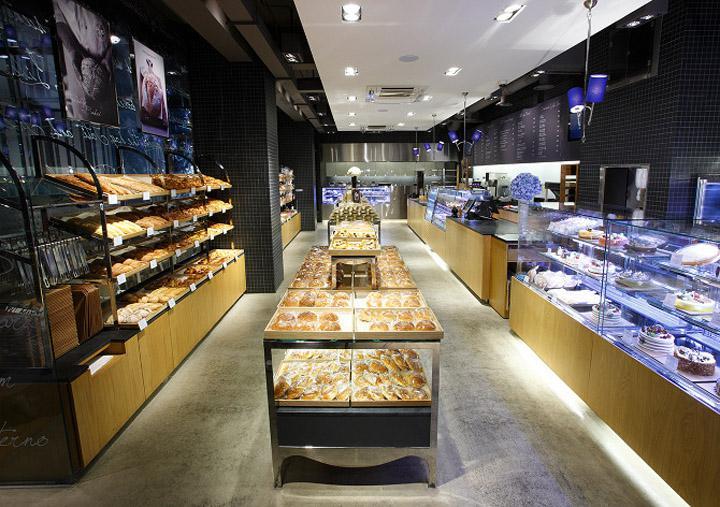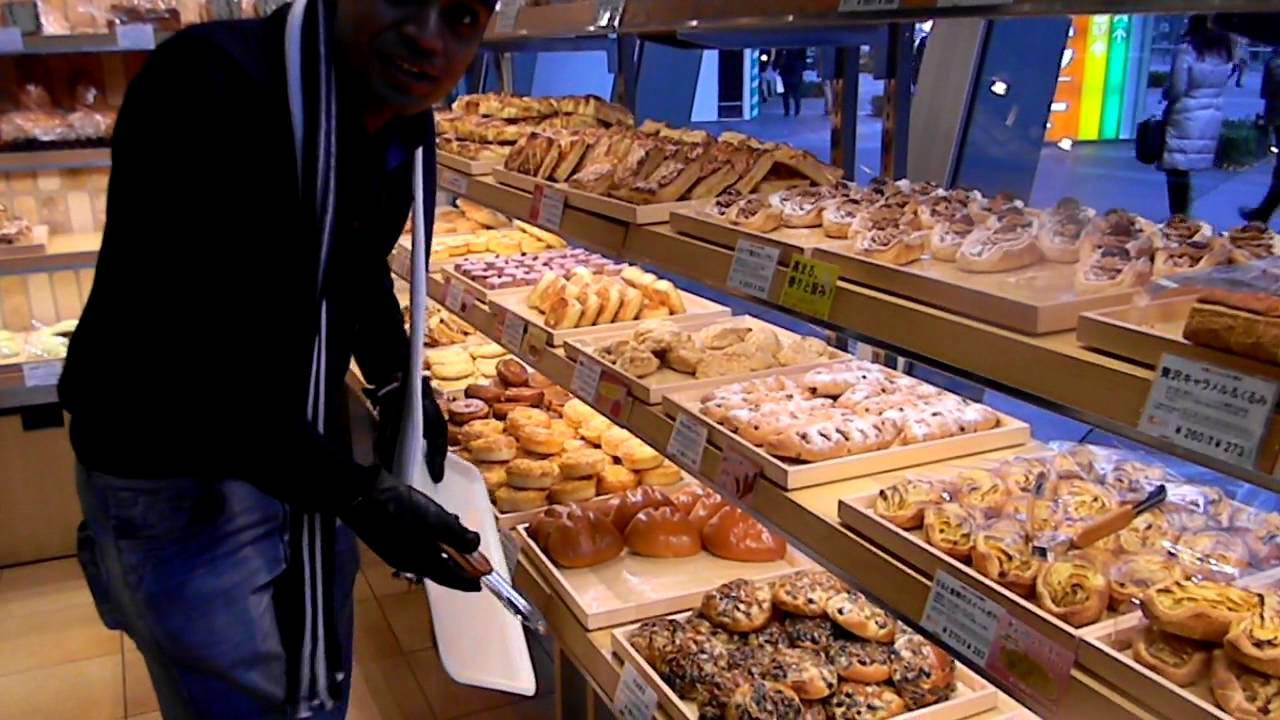The first image is the image on the left, the second image is the image on the right. Examine the images to the left and right. Is the description "There are visible workers behind the the bakers cookie and brownie display case." accurate? Answer yes or no. No. The first image is the image on the left, the second image is the image on the right. Evaluate the accuracy of this statement regarding the images: "Only one person is visible in the image.". Is it true? Answer yes or no. Yes. 